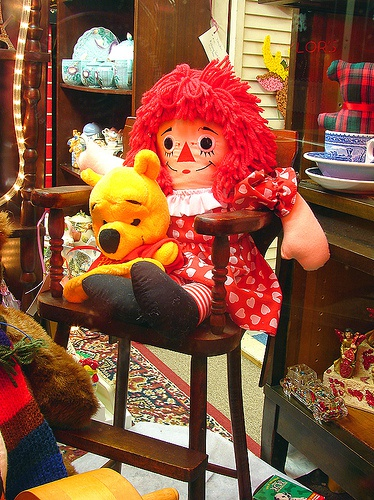Describe the objects in this image and their specific colors. I can see chair in brown, black, maroon, and ivory tones, teddy bear in brown, black, maroon, olive, and red tones, teddy bear in brown, orange, gold, red, and yellow tones, teddy bear in brown, black, maroon, and red tones, and cup in brown, white, darkgray, and blue tones in this image. 